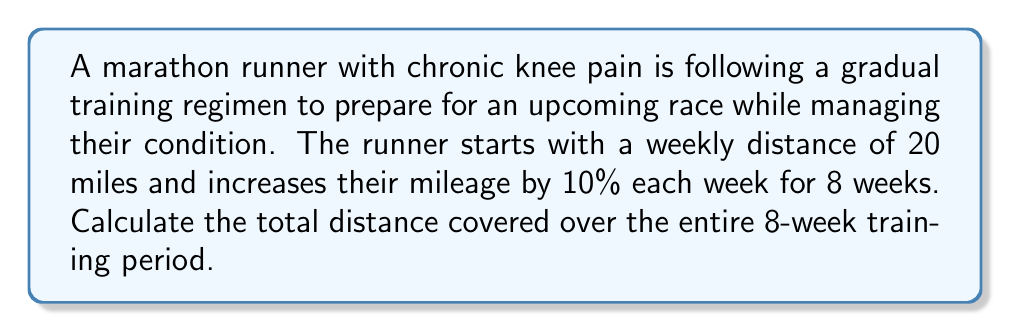Give your solution to this math problem. Let's approach this step-by-step:

1) First, we need to calculate the distance for each week:

   Week 1: 20 miles
   Week 2: $20 \times 1.1 = 22$ miles
   Week 3: $22 \times 1.1 = 24.2$ miles
   Week 4: $24.2 \times 1.1 = 26.62$ miles
   Week 5: $26.62 \times 1.1 = 29.282$ miles
   Week 6: $29.282 \times 1.1 = 32.2102$ miles
   Week 7: $32.2102 \times 1.1 = 35.43122$ miles
   Week 8: $35.43122 \times 1.1 = 38.974342$ miles

2) Now, we need to sum up all these distances:

   $$\text{Total Distance} = 20 + 22 + 24.2 + 26.62 + 29.282 + 32.2102 + 35.43122 + 38.974342$$

3) Using a calculator or computer to sum these numbers:

   $$\text{Total Distance} = 228.69796\text{ miles}$$

4) Rounding to two decimal places for practical purposes:

   $$\text{Total Distance} \approx 228.70\text{ miles}$$

This gradual increase in mileage allows the runner to build endurance while minimizing stress on their knee, which is crucial for managing chronic knee pain.
Answer: The total distance covered over the 8-week training period is approximately 228.70 miles. 